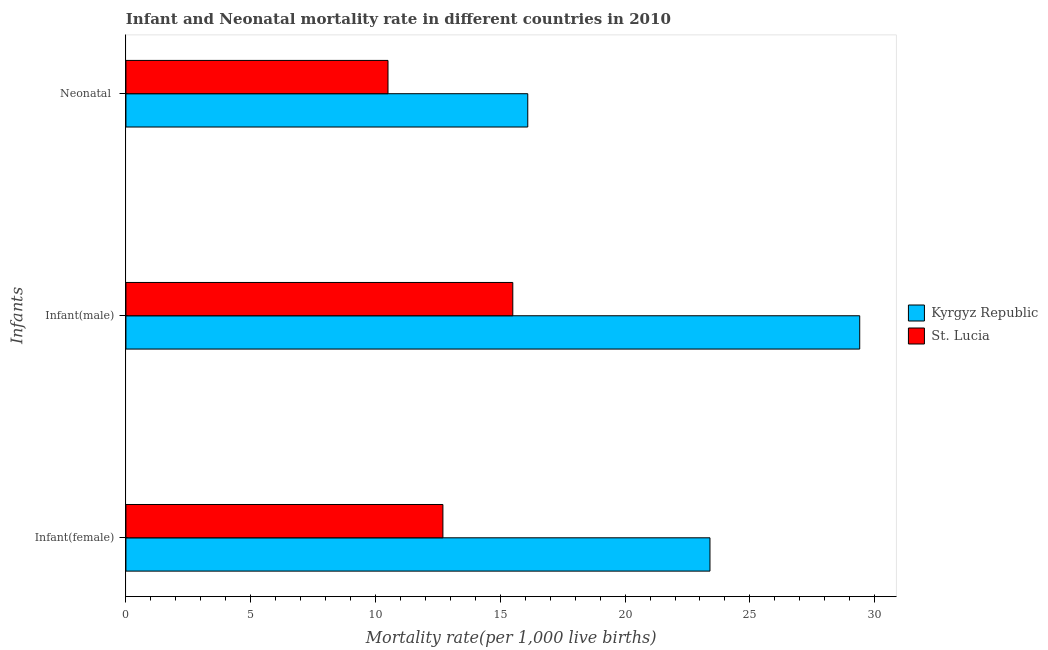How many different coloured bars are there?
Your answer should be compact. 2. Are the number of bars on each tick of the Y-axis equal?
Make the answer very short. Yes. How many bars are there on the 3rd tick from the bottom?
Offer a very short reply. 2. What is the label of the 2nd group of bars from the top?
Your answer should be very brief. Infant(male). What is the infant mortality rate(male) in Kyrgyz Republic?
Ensure brevity in your answer.  29.4. Across all countries, what is the maximum infant mortality rate(female)?
Provide a short and direct response. 23.4. Across all countries, what is the minimum neonatal mortality rate?
Ensure brevity in your answer.  10.5. In which country was the infant mortality rate(male) maximum?
Offer a very short reply. Kyrgyz Republic. In which country was the infant mortality rate(male) minimum?
Offer a very short reply. St. Lucia. What is the total infant mortality rate(female) in the graph?
Provide a succinct answer. 36.1. What is the difference between the infant mortality rate(female) in St. Lucia and the infant mortality rate(male) in Kyrgyz Republic?
Your response must be concise. -16.7. What is the average neonatal mortality rate per country?
Your answer should be compact. 13.3. What is the difference between the infant mortality rate(male) and infant mortality rate(female) in St. Lucia?
Offer a very short reply. 2.8. In how many countries, is the neonatal mortality rate greater than 5 ?
Give a very brief answer. 2. What is the ratio of the infant mortality rate(female) in St. Lucia to that in Kyrgyz Republic?
Your answer should be compact. 0.54. Is the difference between the infant mortality rate(male) in St. Lucia and Kyrgyz Republic greater than the difference between the infant mortality rate(female) in St. Lucia and Kyrgyz Republic?
Your answer should be very brief. No. What is the difference between the highest and the lowest infant mortality rate(male)?
Your response must be concise. 13.9. In how many countries, is the infant mortality rate(male) greater than the average infant mortality rate(male) taken over all countries?
Provide a short and direct response. 1. What does the 2nd bar from the top in Infant(male) represents?
Your answer should be compact. Kyrgyz Republic. What does the 1st bar from the bottom in Neonatal  represents?
Keep it short and to the point. Kyrgyz Republic. Is it the case that in every country, the sum of the infant mortality rate(female) and infant mortality rate(male) is greater than the neonatal mortality rate?
Ensure brevity in your answer.  Yes. How many bars are there?
Give a very brief answer. 6. Are all the bars in the graph horizontal?
Provide a short and direct response. Yes. Does the graph contain any zero values?
Keep it short and to the point. No. Does the graph contain grids?
Provide a short and direct response. No. Where does the legend appear in the graph?
Provide a succinct answer. Center right. How many legend labels are there?
Offer a terse response. 2. What is the title of the graph?
Offer a terse response. Infant and Neonatal mortality rate in different countries in 2010. Does "Vietnam" appear as one of the legend labels in the graph?
Provide a succinct answer. No. What is the label or title of the X-axis?
Your answer should be very brief. Mortality rate(per 1,0 live births). What is the label or title of the Y-axis?
Ensure brevity in your answer.  Infants. What is the Mortality rate(per 1,000 live births) of Kyrgyz Republic in Infant(female)?
Your answer should be very brief. 23.4. What is the Mortality rate(per 1,000 live births) of Kyrgyz Republic in Infant(male)?
Keep it short and to the point. 29.4. Across all Infants, what is the maximum Mortality rate(per 1,000 live births) of Kyrgyz Republic?
Your answer should be compact. 29.4. Across all Infants, what is the maximum Mortality rate(per 1,000 live births) in St. Lucia?
Give a very brief answer. 15.5. Across all Infants, what is the minimum Mortality rate(per 1,000 live births) of Kyrgyz Republic?
Your response must be concise. 16.1. What is the total Mortality rate(per 1,000 live births) in Kyrgyz Republic in the graph?
Keep it short and to the point. 68.9. What is the total Mortality rate(per 1,000 live births) in St. Lucia in the graph?
Ensure brevity in your answer.  38.7. What is the difference between the Mortality rate(per 1,000 live births) in Kyrgyz Republic in Infant(female) and that in Infant(male)?
Provide a succinct answer. -6. What is the difference between the Mortality rate(per 1,000 live births) in St. Lucia in Infant(female) and that in Infant(male)?
Make the answer very short. -2.8. What is the difference between the Mortality rate(per 1,000 live births) of St. Lucia in Infant(female) and that in Neonatal ?
Make the answer very short. 2.2. What is the difference between the Mortality rate(per 1,000 live births) in Kyrgyz Republic in Infant(male) and that in Neonatal ?
Ensure brevity in your answer.  13.3. What is the difference between the Mortality rate(per 1,000 live births) in St. Lucia in Infant(male) and that in Neonatal ?
Your answer should be compact. 5. What is the difference between the Mortality rate(per 1,000 live births) of Kyrgyz Republic in Infant(male) and the Mortality rate(per 1,000 live births) of St. Lucia in Neonatal ?
Provide a short and direct response. 18.9. What is the average Mortality rate(per 1,000 live births) in Kyrgyz Republic per Infants?
Your response must be concise. 22.97. What is the difference between the Mortality rate(per 1,000 live births) of Kyrgyz Republic and Mortality rate(per 1,000 live births) of St. Lucia in Infant(female)?
Keep it short and to the point. 10.7. What is the difference between the Mortality rate(per 1,000 live births) in Kyrgyz Republic and Mortality rate(per 1,000 live births) in St. Lucia in Infant(male)?
Your answer should be compact. 13.9. What is the difference between the Mortality rate(per 1,000 live births) of Kyrgyz Republic and Mortality rate(per 1,000 live births) of St. Lucia in Neonatal ?
Offer a very short reply. 5.6. What is the ratio of the Mortality rate(per 1,000 live births) in Kyrgyz Republic in Infant(female) to that in Infant(male)?
Your answer should be compact. 0.8. What is the ratio of the Mortality rate(per 1,000 live births) in St. Lucia in Infant(female) to that in Infant(male)?
Your answer should be very brief. 0.82. What is the ratio of the Mortality rate(per 1,000 live births) in Kyrgyz Republic in Infant(female) to that in Neonatal ?
Give a very brief answer. 1.45. What is the ratio of the Mortality rate(per 1,000 live births) in St. Lucia in Infant(female) to that in Neonatal ?
Provide a short and direct response. 1.21. What is the ratio of the Mortality rate(per 1,000 live births) of Kyrgyz Republic in Infant(male) to that in Neonatal ?
Your response must be concise. 1.83. What is the ratio of the Mortality rate(per 1,000 live births) in St. Lucia in Infant(male) to that in Neonatal ?
Give a very brief answer. 1.48. What is the difference between the highest and the second highest Mortality rate(per 1,000 live births) of Kyrgyz Republic?
Give a very brief answer. 6. What is the difference between the highest and the second highest Mortality rate(per 1,000 live births) in St. Lucia?
Ensure brevity in your answer.  2.8. What is the difference between the highest and the lowest Mortality rate(per 1,000 live births) of Kyrgyz Republic?
Make the answer very short. 13.3. What is the difference between the highest and the lowest Mortality rate(per 1,000 live births) of St. Lucia?
Your response must be concise. 5. 